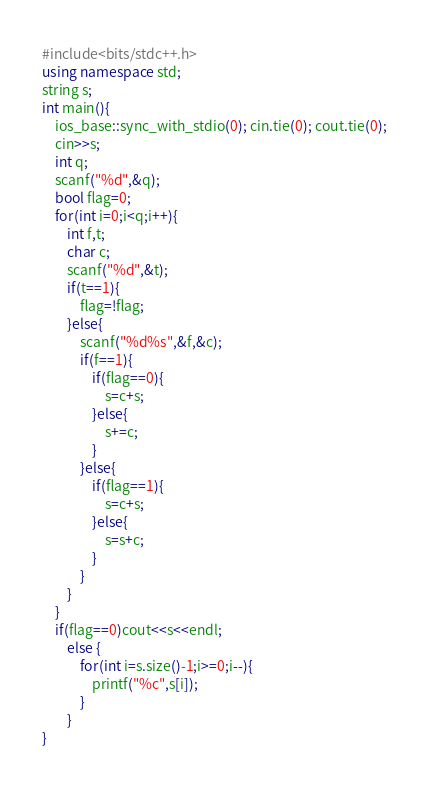<code> <loc_0><loc_0><loc_500><loc_500><_C++_>#include<bits/stdc++.h>
using namespace std;
string s;
int main(){
	ios_base::sync_with_stdio(0); cin.tie(0); cout.tie(0);
	cin>>s;
	int q;
	scanf("%d",&q);
	bool flag=0;
	for(int i=0;i<q;i++){
		int f,t;
		char c;
		scanf("%d",&t);
		if(t==1){
			flag=!flag;
		}else{
			scanf("%d%s",&f,&c);
			if(f==1){
				if(flag==0){
					s=c+s;
				}else{
					s+=c;
				}
			}else{
				if(flag==1){
					s=c+s;
				}else{
					s=s+c;
				}
			}
		}
	}
	if(flag==0)cout<<s<<endl;
		else {
			for(int i=s.size()-1;i>=0;i--){
				printf("%c",s[i]);
			}
		}
}</code> 